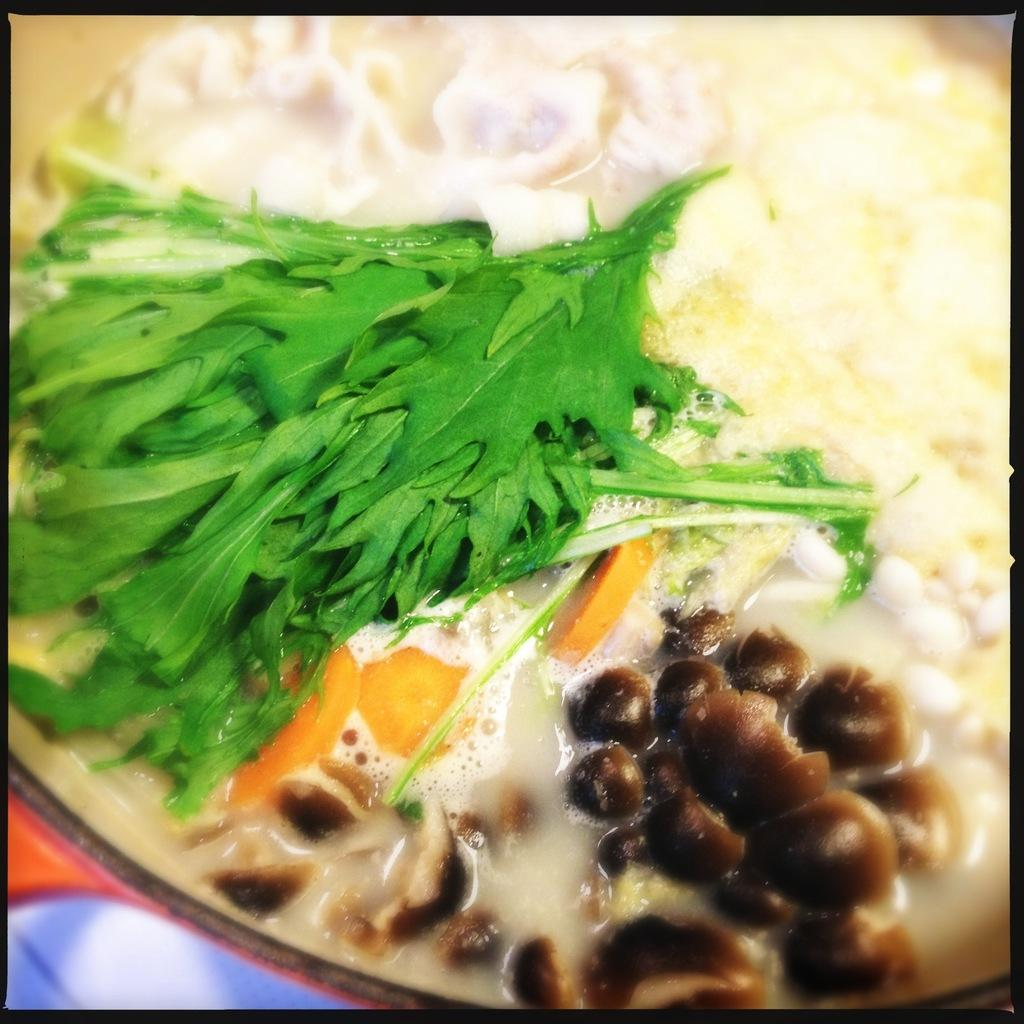What is in the bowl that is visible in the image? There is a bowl containing soup in the image. What feature can be observed around the edges of the image? The image has borders. What type of joke is being told by the soup in the image? There is no joke being told by the soup in the image, as it is a bowl of soup and not capable of telling jokes. 